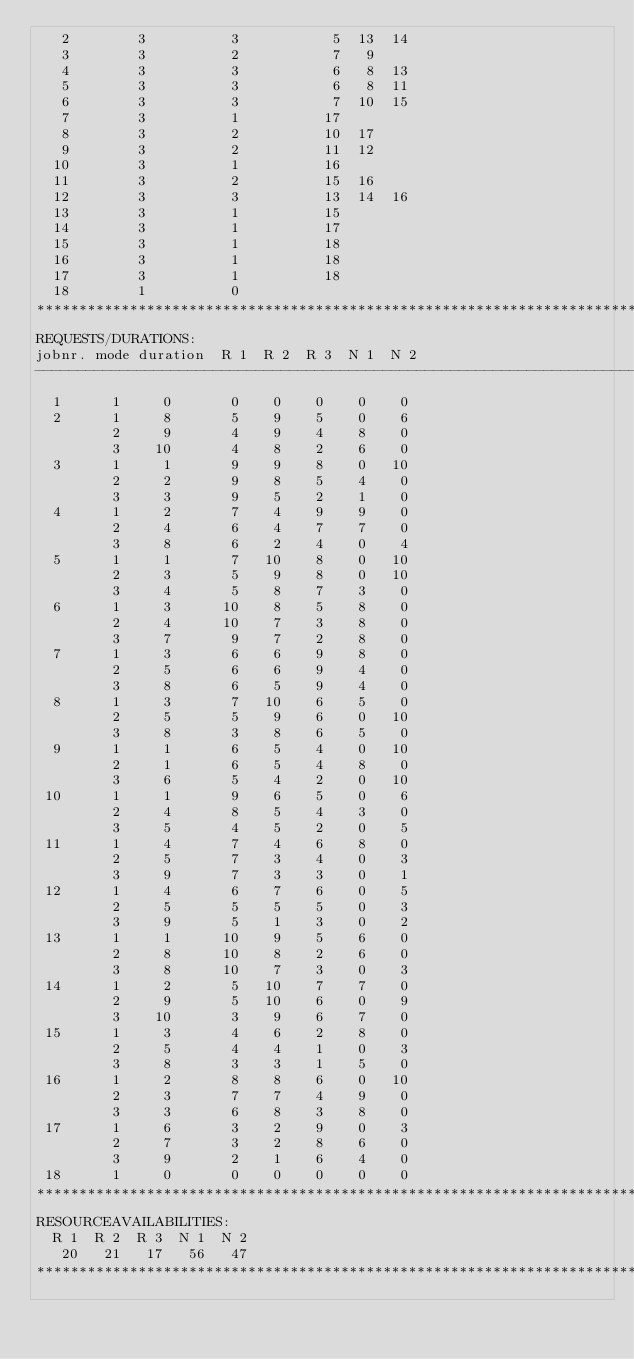<code> <loc_0><loc_0><loc_500><loc_500><_ObjectiveC_>   2        3          3           5  13  14
   3        3          2           7   9
   4        3          3           6   8  13
   5        3          3           6   8  11
   6        3          3           7  10  15
   7        3          1          17
   8        3          2          10  17
   9        3          2          11  12
  10        3          1          16
  11        3          2          15  16
  12        3          3          13  14  16
  13        3          1          15
  14        3          1          17
  15        3          1          18
  16        3          1          18
  17        3          1          18
  18        1          0        
************************************************************************
REQUESTS/DURATIONS:
jobnr. mode duration  R 1  R 2  R 3  N 1  N 2
------------------------------------------------------------------------
  1      1     0       0    0    0    0    0
  2      1     8       5    9    5    0    6
         2     9       4    9    4    8    0
         3    10       4    8    2    6    0
  3      1     1       9    9    8    0   10
         2     2       9    8    5    4    0
         3     3       9    5    2    1    0
  4      1     2       7    4    9    9    0
         2     4       6    4    7    7    0
         3     8       6    2    4    0    4
  5      1     1       7   10    8    0   10
         2     3       5    9    8    0   10
         3     4       5    8    7    3    0
  6      1     3      10    8    5    8    0
         2     4      10    7    3    8    0
         3     7       9    7    2    8    0
  7      1     3       6    6    9    8    0
         2     5       6    6    9    4    0
         3     8       6    5    9    4    0
  8      1     3       7   10    6    5    0
         2     5       5    9    6    0   10
         3     8       3    8    6    5    0
  9      1     1       6    5    4    0   10
         2     1       6    5    4    8    0
         3     6       5    4    2    0   10
 10      1     1       9    6    5    0    6
         2     4       8    5    4    3    0
         3     5       4    5    2    0    5
 11      1     4       7    4    6    8    0
         2     5       7    3    4    0    3
         3     9       7    3    3    0    1
 12      1     4       6    7    6    0    5
         2     5       5    5    5    0    3
         3     9       5    1    3    0    2
 13      1     1      10    9    5    6    0
         2     8      10    8    2    6    0
         3     8      10    7    3    0    3
 14      1     2       5   10    7    7    0
         2     9       5   10    6    0    9
         3    10       3    9    6    7    0
 15      1     3       4    6    2    8    0
         2     5       4    4    1    0    3
         3     8       3    3    1    5    0
 16      1     2       8    8    6    0   10
         2     3       7    7    4    9    0
         3     3       6    8    3    8    0
 17      1     6       3    2    9    0    3
         2     7       3    2    8    6    0
         3     9       2    1    6    4    0
 18      1     0       0    0    0    0    0
************************************************************************
RESOURCEAVAILABILITIES:
  R 1  R 2  R 3  N 1  N 2
   20   21   17   56   47
************************************************************************
</code> 